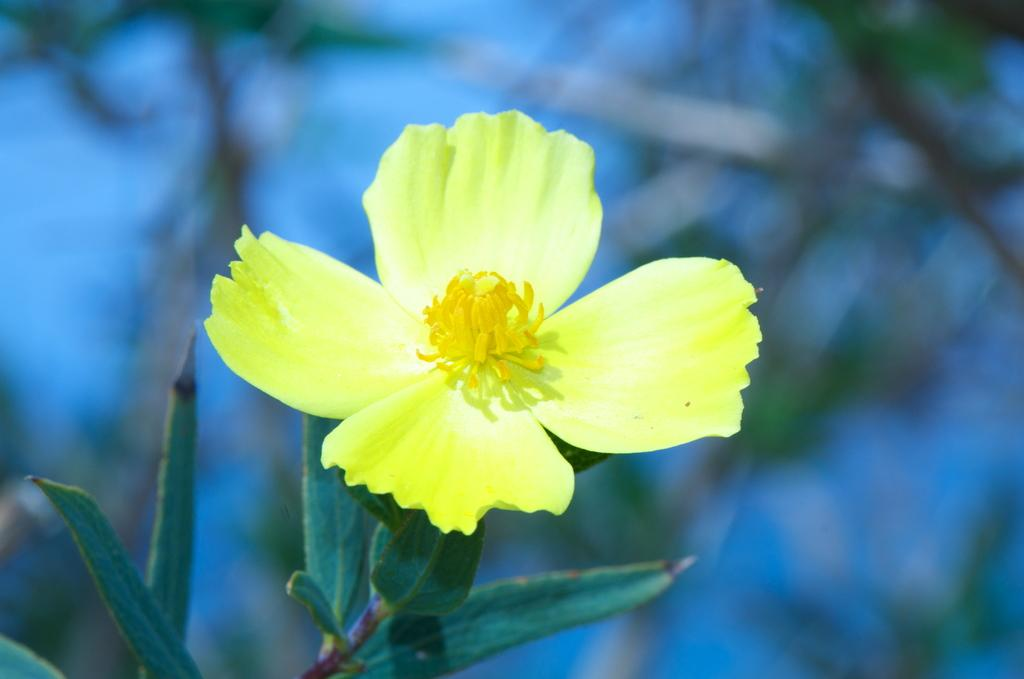What type of flower is present in the image? There is a yellow flower in the image. Can you describe the background of the image? The background of the image is blurred. Is there any rain visible in the image? There is no rain present in the image. What type of wilderness can be seen in the background of the image? The background of the image is blurred, and there is no wilderness visible. 